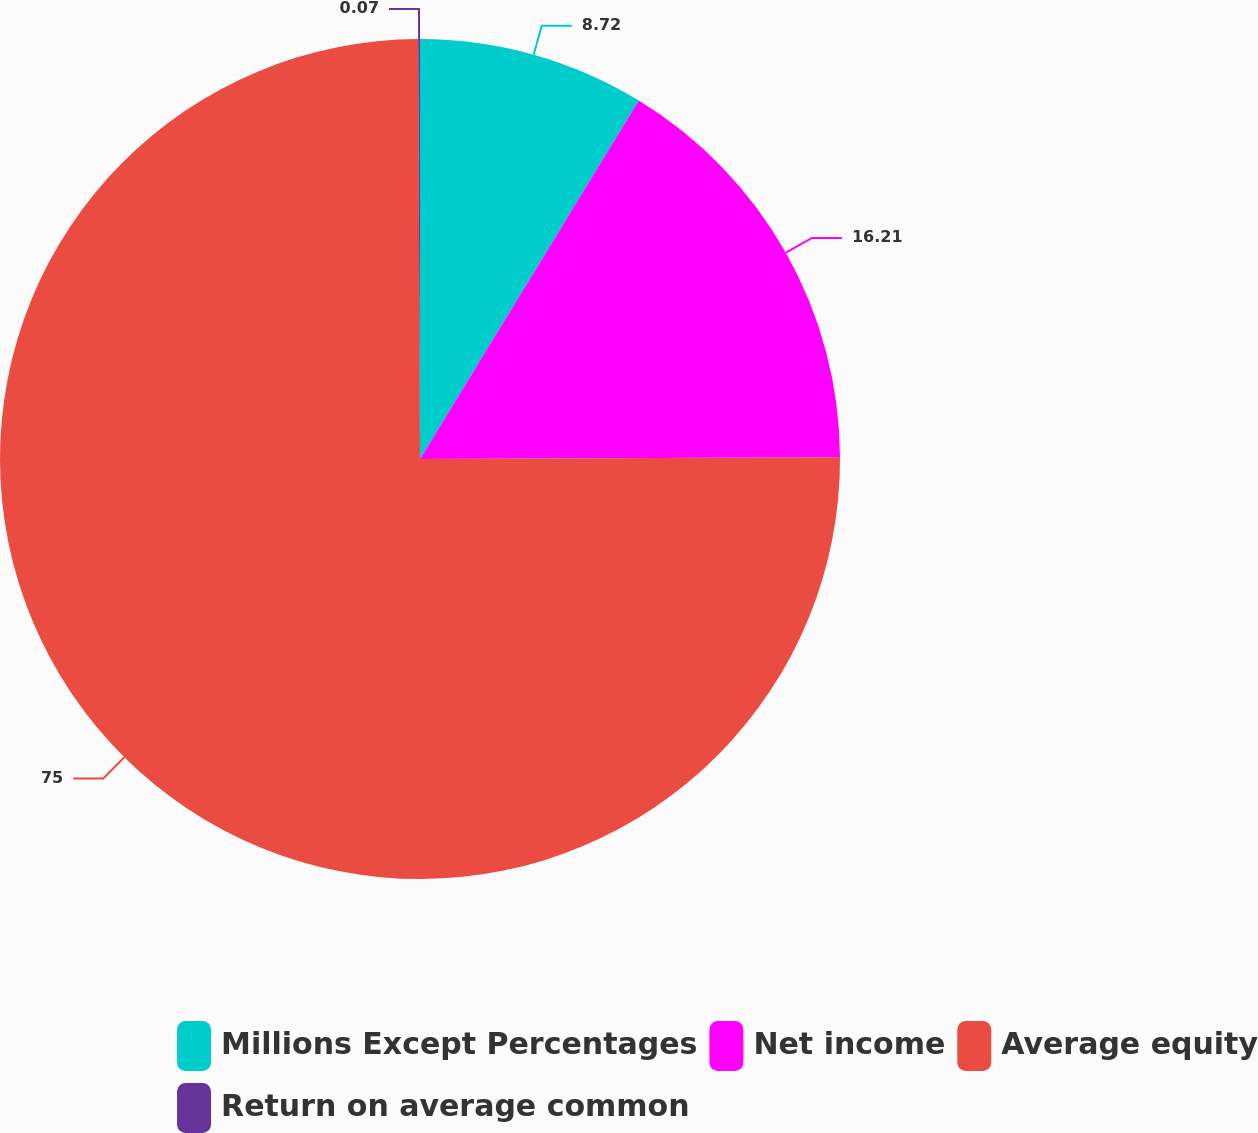Convert chart. <chart><loc_0><loc_0><loc_500><loc_500><pie_chart><fcel>Millions Except Percentages<fcel>Net income<fcel>Average equity<fcel>Return on average common<nl><fcel>8.72%<fcel>16.21%<fcel>74.99%<fcel>0.07%<nl></chart> 